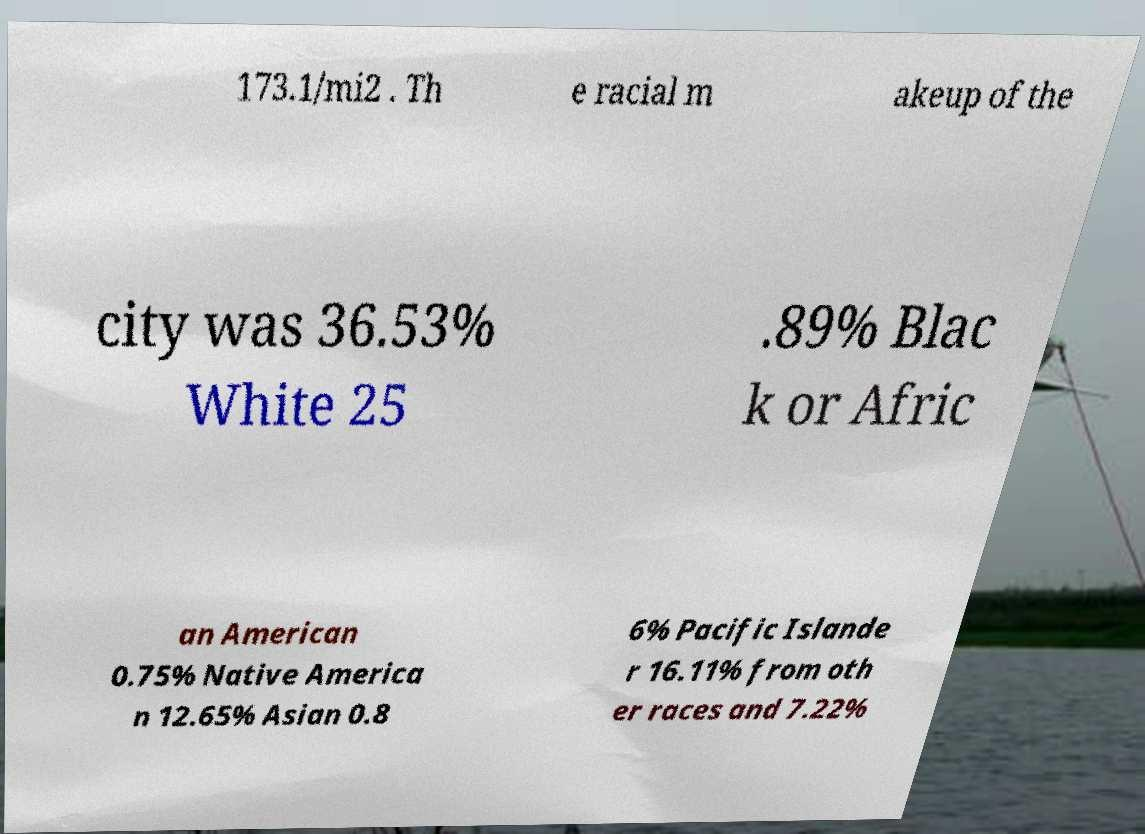Can you accurately transcribe the text from the provided image for me? 173.1/mi2 . Th e racial m akeup of the city was 36.53% White 25 .89% Blac k or Afric an American 0.75% Native America n 12.65% Asian 0.8 6% Pacific Islande r 16.11% from oth er races and 7.22% 